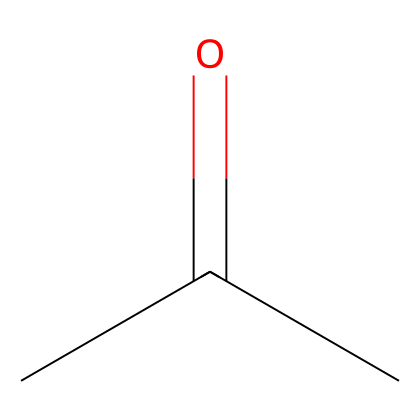What is the molecular formula of this compound? The SMILES representation shows the atoms present: two carbon (C) atoms from the "CC" part and one oxygen (O) atom from the "=O" part. Therefore, the molecular formula is C3H6O, considering hydrogen atoms bonded to carbon atoms.
Answer: C3H6O How many carbon atoms are in this structure? In the SMILES representation "CC(=O)C," there are three carbon atoms denoted by "C" including the two in the chain and one part of the carbonyl group "C(=O)."
Answer: 3 Is this compound a ketone, aldehyde, or alcohol? The structure contains a carbonyl group (C=O) flanked by two carbon atoms (C-C), which confirms it is a ketone, as ketones have carbonyl groups between two carbon atoms.
Answer: ketone What type of functional group is present in this compound? The "(=O)" notation indicates a carbonyl functional group, which is characteristic of ketones and aldehydes. In this case, it's specifically flanked by carbon atoms, identifying it as a ketone.
Answer: carbonyl What is the common name for this ketone? The compound with the structure CC(=O)C is commonly known as acetone, which is widely used as a solvent in various applications, including film development processes.
Answer: acetone How many hydrogen atoms are bonded to the central carbon atom? In the structure, the central carbon atom has one double bond to oxygen (due to the carbonyl) and is bonded to two other carbon atoms, leading to one remaining bond with a hydrogen atom.
Answer: 1 What role does acetone play in film development? Acetone is used as a solvent in film development processes to dissolve, thin, and clean components, making it essential for preparing photographic film.
Answer: solvent 